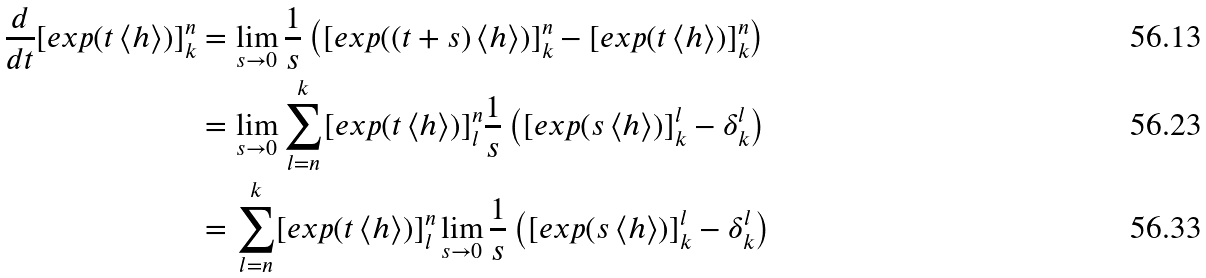<formula> <loc_0><loc_0><loc_500><loc_500>\frac { d } { d t } [ e x p ( t \left < h \right > ) ] ^ { n } _ { k } & = \lim _ { s \rightarrow 0 } \frac { 1 } { s } \left ( [ e x p ( ( t + s ) \left < h \right > ) ] ^ { n } _ { k } - [ e x p ( t \left < h \right > ) ] ^ { n } _ { k } \right ) \\ & = \lim _ { s \rightarrow 0 } \sum _ { l = n } ^ { k } [ e x p ( t \left < h \right > ) ] ^ { n } _ { l } \frac { 1 } { s } \left ( [ e x p ( s \left < h \right > ) ] ^ { l } _ { k } - \delta ^ { l } _ { k } \right ) \\ & = \sum _ { l = n } ^ { k } [ e x p ( t \left < h \right > ) ] ^ { n } _ { l } \lim _ { s \rightarrow 0 } \frac { 1 } { s } \left ( [ e x p ( s \left < h \right > ) ] ^ { l } _ { k } - \delta ^ { l } _ { k } \right )</formula> 